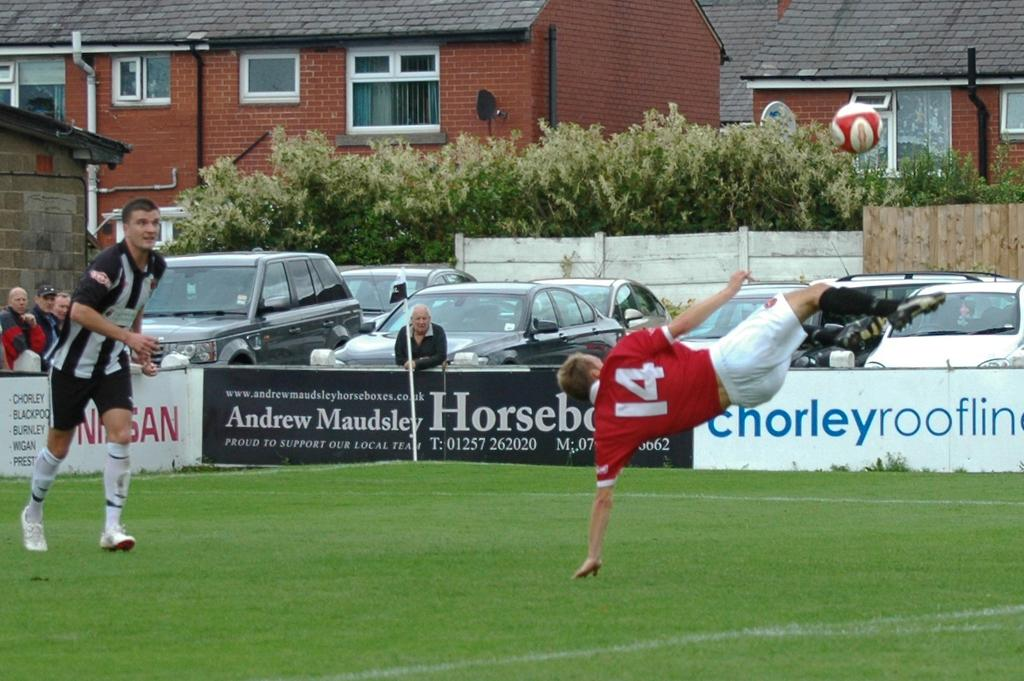<image>
Describe the image concisely. Player number 14 is sideways as he kicks at the soccer ball. 